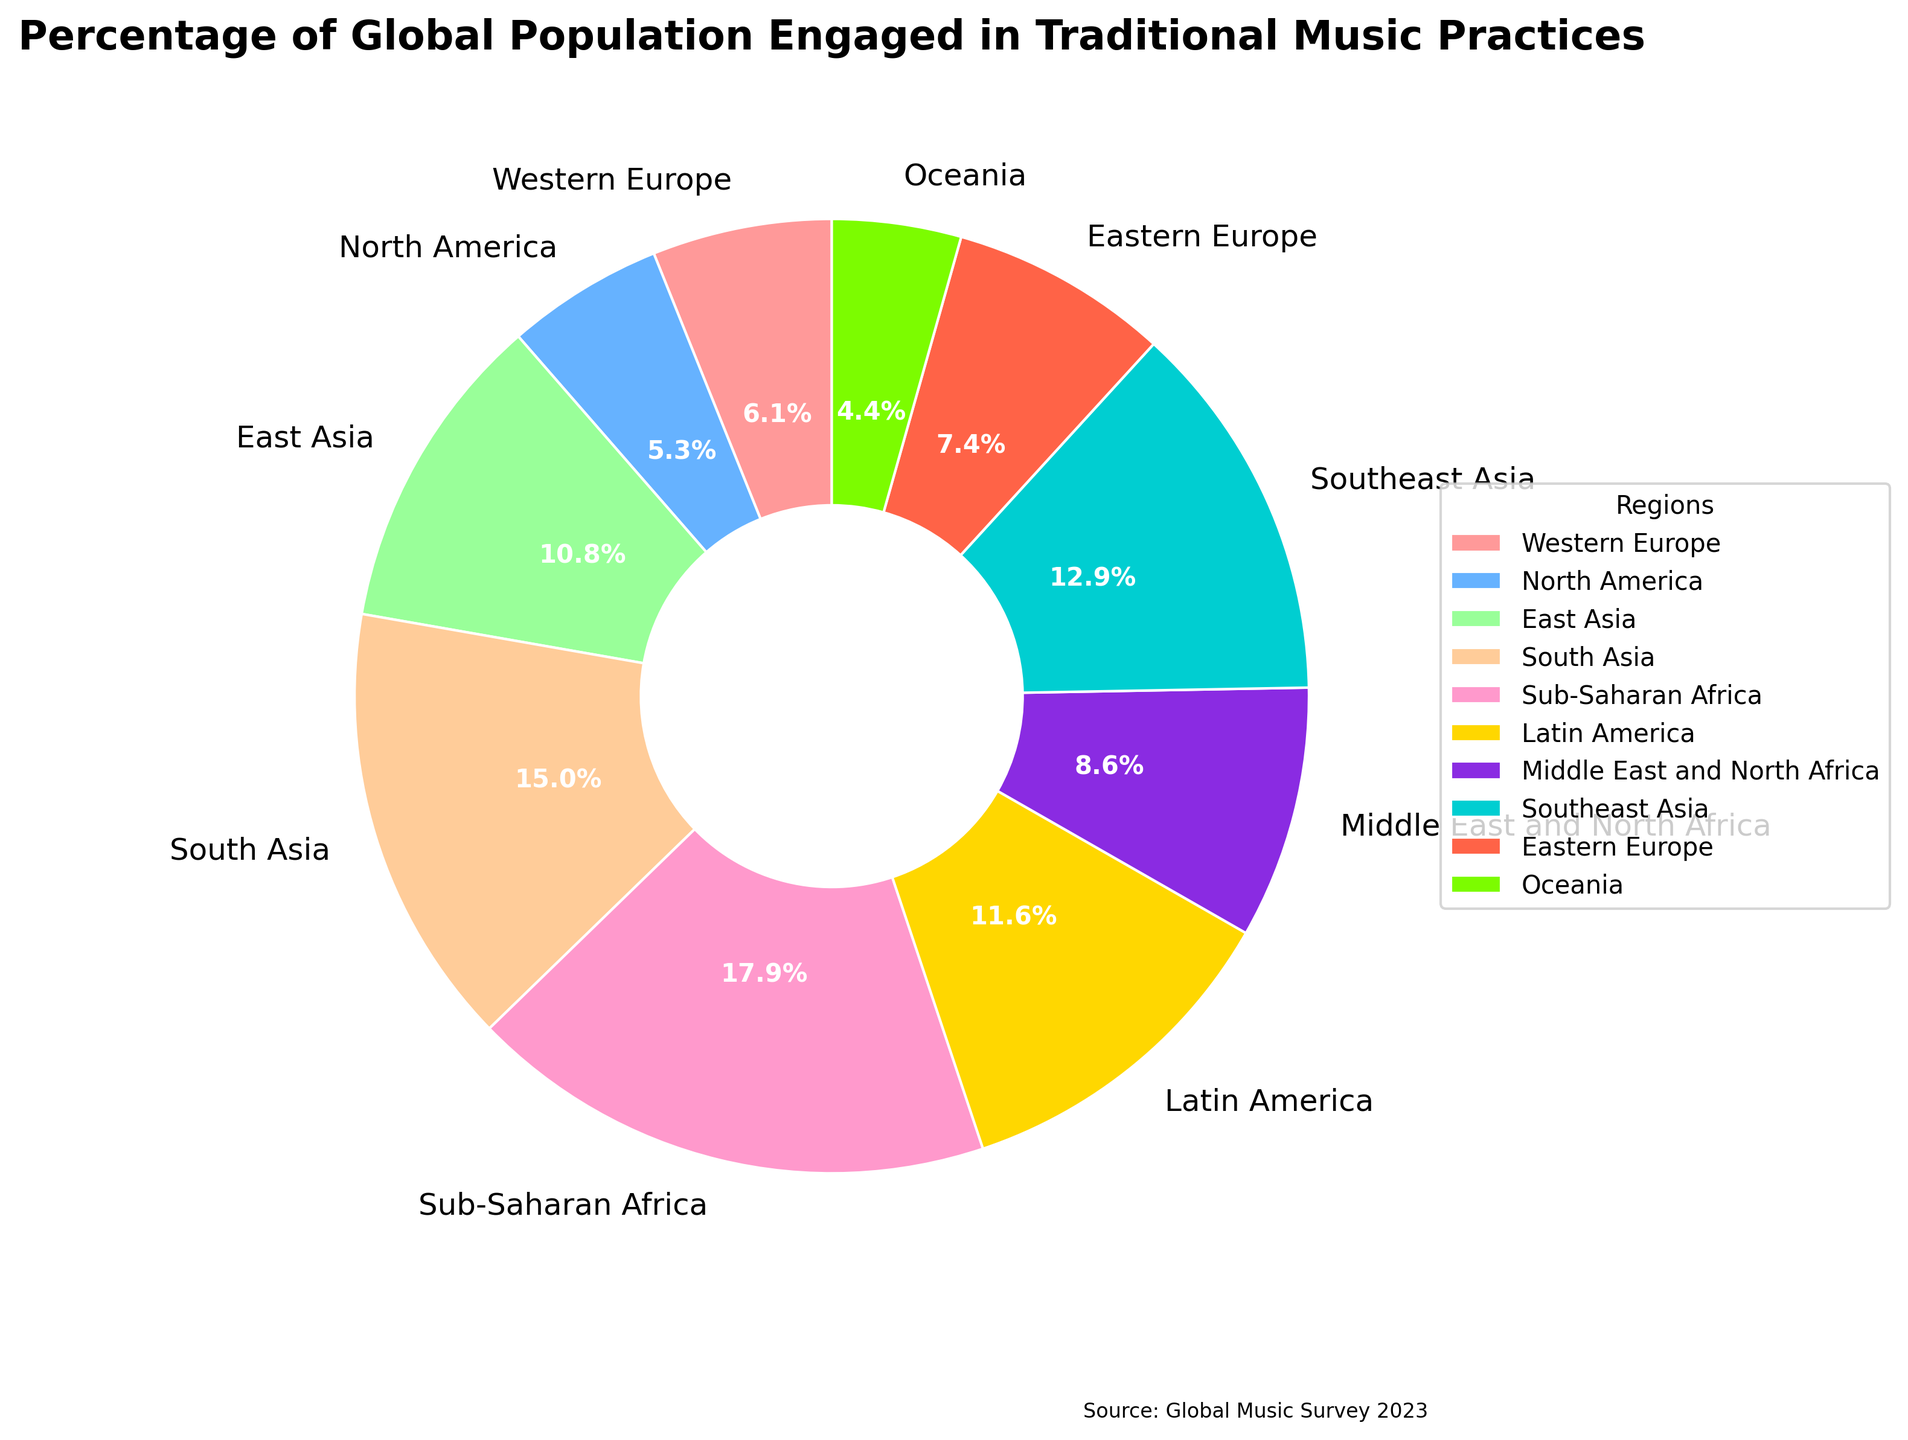What region has the highest percentage of global population engaged in traditional music practices? By looking at the pie chart, we can see the size of the slices. The largest slice corresponds to Sub-Saharan Africa, indicating it has the highest percentage.
Answer: Sub-Saharan Africa How many regions have a percentage greater than 5%? From the pie chart, we observe that slices for East Asia, South Asia, Sub-Saharan Africa, Latin America, and Southeast Asia exceed 5%. Counting these, we get five regions.
Answer: 5 What is the sum of the percentages for Western Europe and North America? According to the pie chart, the percentage for Western Europe is 3.2%, and for North America is 2.8%. Adding these together, 3.2% + 2.8% = 6%.
Answer: 6% Which regions have a lower percentage than Latin America but higher than North America? Latin America has 6.1%, and North America has 2.8%. The regions between these values are Western Europe (3.2%), Eastern Europe (3.9%), Middle East and North Africa (4.5%), and Southeast Asia (6.8%).
Answer: Western Europe, Eastern Europe, Middle East and North Africa What is the total percentage accounted for by Eastern Europe and Oceania? The pie chart indicates that Eastern Europe is at 3.9% and Oceania is at 2.3%. Adding these together, 3.9% + 2.3% = 6.2%.
Answer: 6.2% Which region representing the highest percentage is colored the brightest hue? The pie chart shows that the brightest hue (bright yellow) corresponds to Sub-Saharan Africa, which has the highest percentage.
Answer: Sub-Saharan Africa What is the average percentage of global population engaged in traditional music practices across all regions? According to the pie chart, we sum all percentages: 3.2% + 2.8% + 5.7% + 7.9% + 9.4% + 6.1% + 4.5% + 6.8% + 3.9% + 2.3% = 52.6%. Dividing by the number of regions (10), the average is 52.6 / 10 = 5.26%.
Answer: 5.26% Which region has the smallest percentage of global population engaged in traditional music practices? Observing the pie chart, the smallest slice is for Oceania, indicating it has the smallest percentage.
Answer: Oceania 